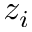Convert formula to latex. <formula><loc_0><loc_0><loc_500><loc_500>z _ { i }</formula> 